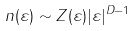Convert formula to latex. <formula><loc_0><loc_0><loc_500><loc_500>n ( \varepsilon ) \sim Z ( \varepsilon ) | \varepsilon | ^ { D - 1 }</formula> 